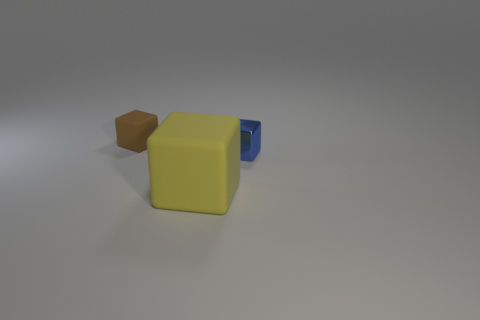Add 3 small cyan objects. How many objects exist? 6 Subtract 0 blue balls. How many objects are left? 3 Subtract all blue things. Subtract all small blue things. How many objects are left? 1 Add 1 big cubes. How many big cubes are left? 2 Add 1 brown rubber cubes. How many brown rubber cubes exist? 2 